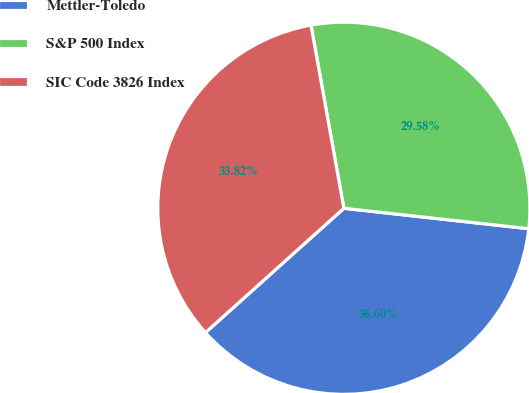Convert chart. <chart><loc_0><loc_0><loc_500><loc_500><pie_chart><fcel>Mettler-Toledo<fcel>S&P 500 Index<fcel>SIC Code 3826 Index<nl><fcel>36.6%<fcel>29.58%<fcel>33.82%<nl></chart> 